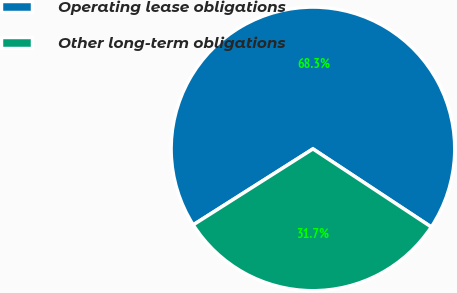Convert chart to OTSL. <chart><loc_0><loc_0><loc_500><loc_500><pie_chart><fcel>Operating lease obligations<fcel>Other long-term obligations<nl><fcel>68.28%<fcel>31.72%<nl></chart> 